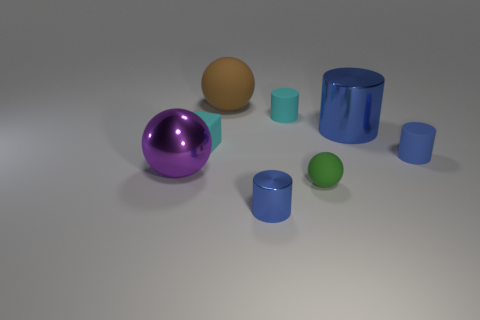How many blue cylinders must be subtracted to get 1 blue cylinders? 2 Add 2 small green rubber balls. How many objects exist? 10 Subtract all big spheres. How many spheres are left? 1 Add 8 cyan matte blocks. How many cyan matte blocks exist? 9 Subtract all blue cylinders. How many cylinders are left? 1 Subtract 0 yellow blocks. How many objects are left? 8 Subtract all balls. How many objects are left? 5 Subtract 1 cubes. How many cubes are left? 0 Subtract all red cylinders. Subtract all purple blocks. How many cylinders are left? 4 Subtract all purple balls. How many purple cylinders are left? 0 